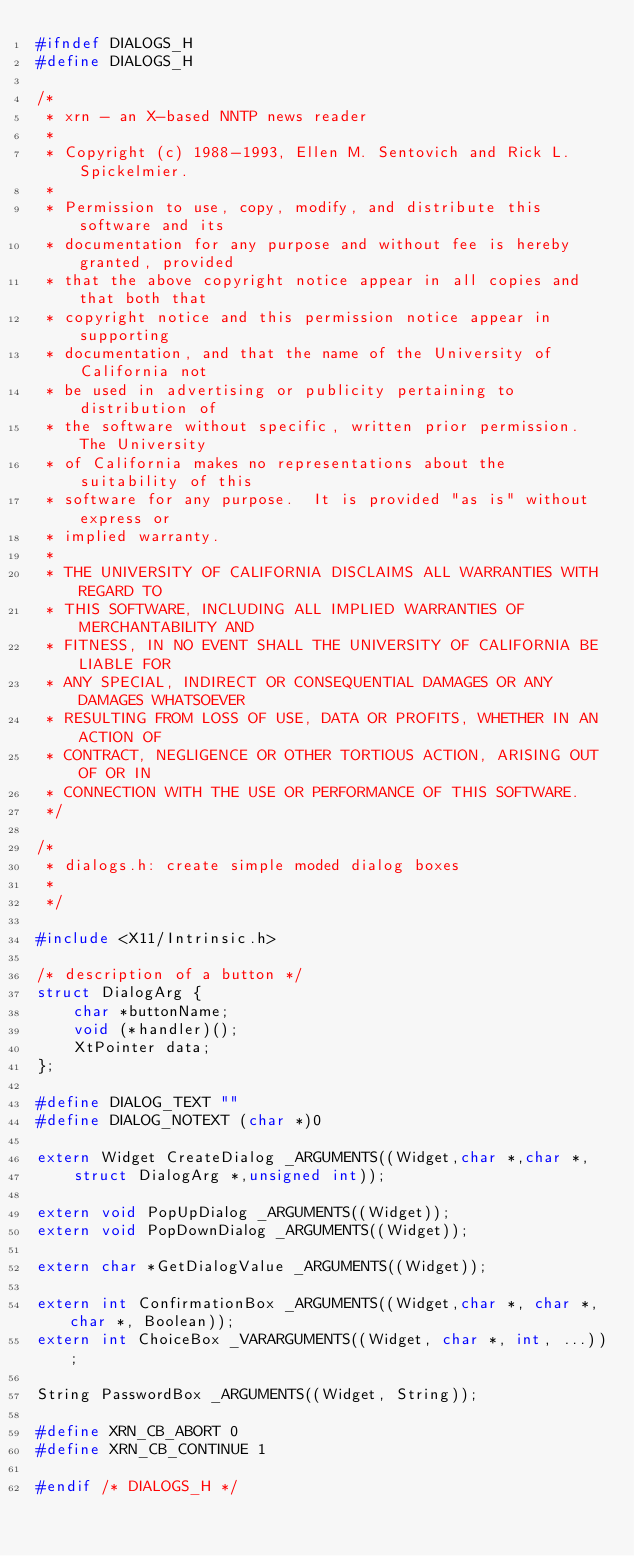<code> <loc_0><loc_0><loc_500><loc_500><_C_>#ifndef DIALOGS_H
#define DIALOGS_H

/*
 * xrn - an X-based NNTP news reader
 *
 * Copyright (c) 1988-1993, Ellen M. Sentovich and Rick L. Spickelmier.
 *
 * Permission to use, copy, modify, and distribute this software and its
 * documentation for any purpose and without fee is hereby granted, provided
 * that the above copyright notice appear in all copies and that both that
 * copyright notice and this permission notice appear in supporting
 * documentation, and that the name of the University of California not
 * be used in advertising or publicity pertaining to distribution of 
 * the software without specific, written prior permission.  The University
 * of California makes no representations about the suitability of this
 * software for any purpose.  It is provided "as is" without express or
 * implied warranty.
 *
 * THE UNIVERSITY OF CALIFORNIA DISCLAIMS ALL WARRANTIES WITH REGARD TO 
 * THIS SOFTWARE, INCLUDING ALL IMPLIED WARRANTIES OF MERCHANTABILITY AND 
 * FITNESS, IN NO EVENT SHALL THE UNIVERSITY OF CALIFORNIA BE LIABLE FOR
 * ANY SPECIAL, INDIRECT OR CONSEQUENTIAL DAMAGES OR ANY DAMAGES WHATSOEVER
 * RESULTING FROM LOSS OF USE, DATA OR PROFITS, WHETHER IN AN ACTION OF
 * CONTRACT, NEGLIGENCE OR OTHER TORTIOUS ACTION, ARISING OUT OF OR IN 
 * CONNECTION WITH THE USE OR PERFORMANCE OF THIS SOFTWARE.
 */

/*
 * dialogs.h: create simple moded dialog boxes
 *
 */

#include <X11/Intrinsic.h>

/* description of a button */
struct DialogArg {
    char *buttonName;
    void (*handler)();
    XtPointer data;
};

#define DIALOG_TEXT ""
#define DIALOG_NOTEXT (char *)0

extern Widget CreateDialog _ARGUMENTS((Widget,char *,char *,
    struct DialogArg *,unsigned int));

extern void PopUpDialog _ARGUMENTS((Widget));
extern void PopDownDialog _ARGUMENTS((Widget));

extern char *GetDialogValue _ARGUMENTS((Widget));

extern int ConfirmationBox _ARGUMENTS((Widget,char *, char *, char *, Boolean));
extern int ChoiceBox _VARARGUMENTS((Widget, char *, int, ...));
				 
String PasswordBox _ARGUMENTS((Widget, String));

#define XRN_CB_ABORT 0
#define XRN_CB_CONTINUE 1

#endif /* DIALOGS_H */

</code> 